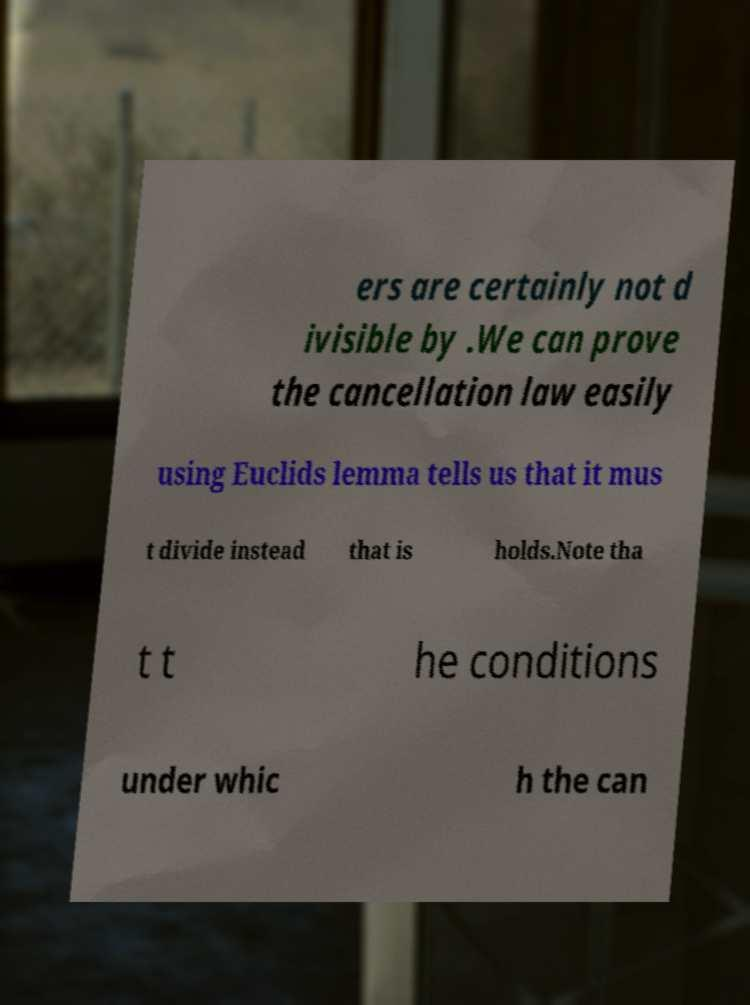Please read and relay the text visible in this image. What does it say? ers are certainly not d ivisible by .We can prove the cancellation law easily using Euclids lemma tells us that it mus t divide instead that is holds.Note tha t t he conditions under whic h the can 